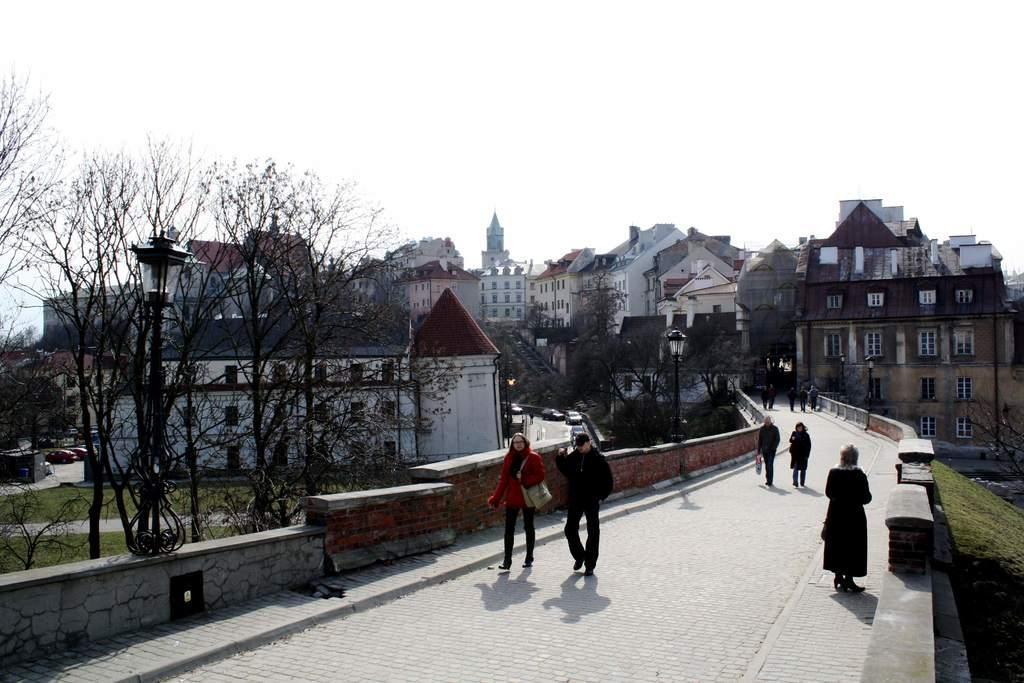Describe this image in one or two sentences. In the picture there are many houses and buildings and few people are walking on a path on the right side, around that path there are many trees and grass. 